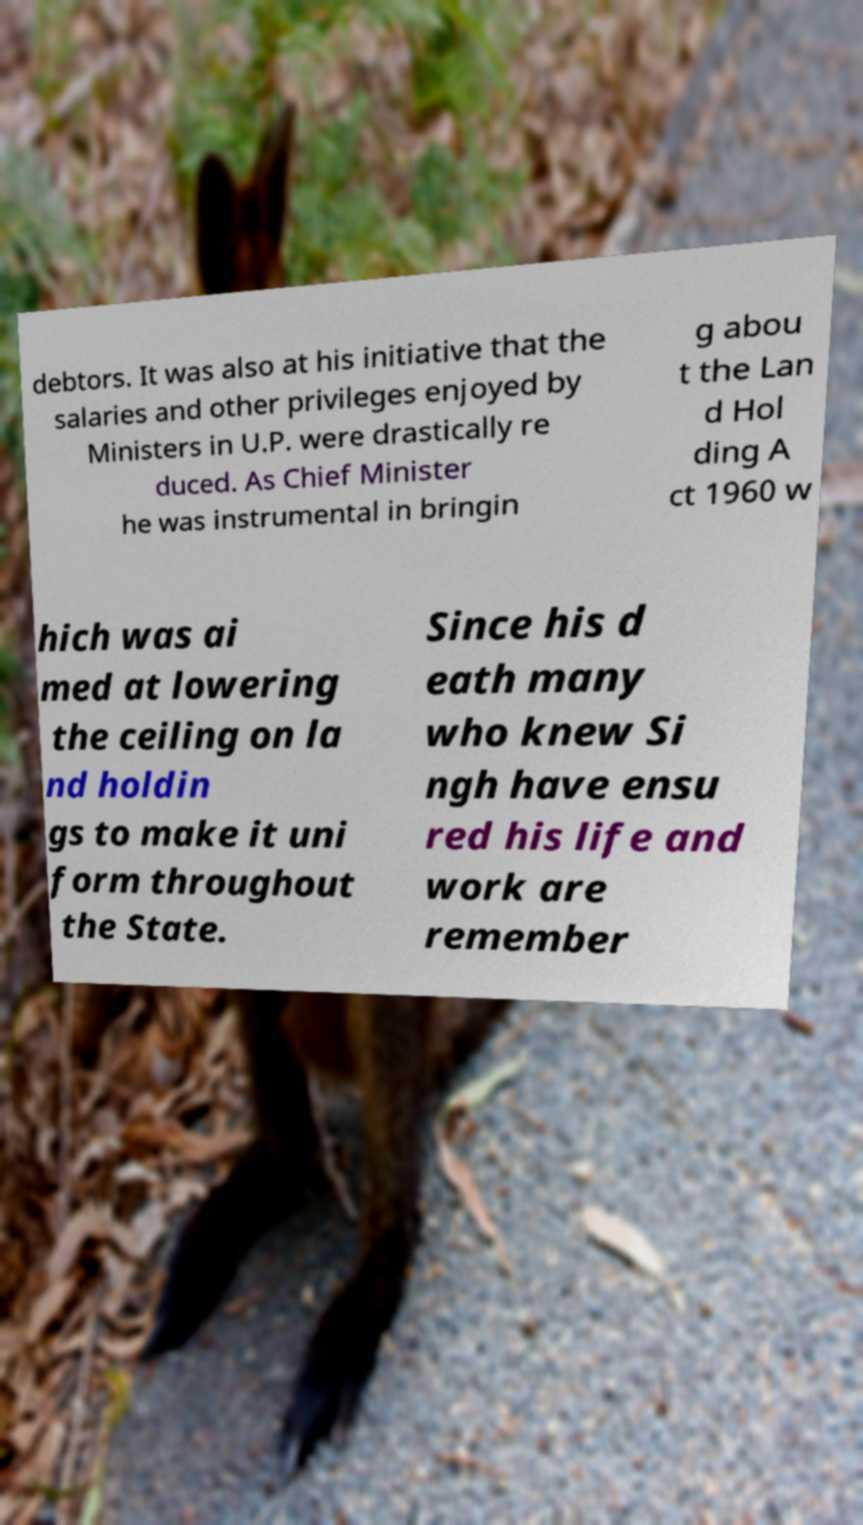Could you assist in decoding the text presented in this image and type it out clearly? debtors. It was also at his initiative that the salaries and other privileges enjoyed by Ministers in U.P. were drastically re duced. As Chief Minister he was instrumental in bringin g abou t the Lan d Hol ding A ct 1960 w hich was ai med at lowering the ceiling on la nd holdin gs to make it uni form throughout the State. Since his d eath many who knew Si ngh have ensu red his life and work are remember 